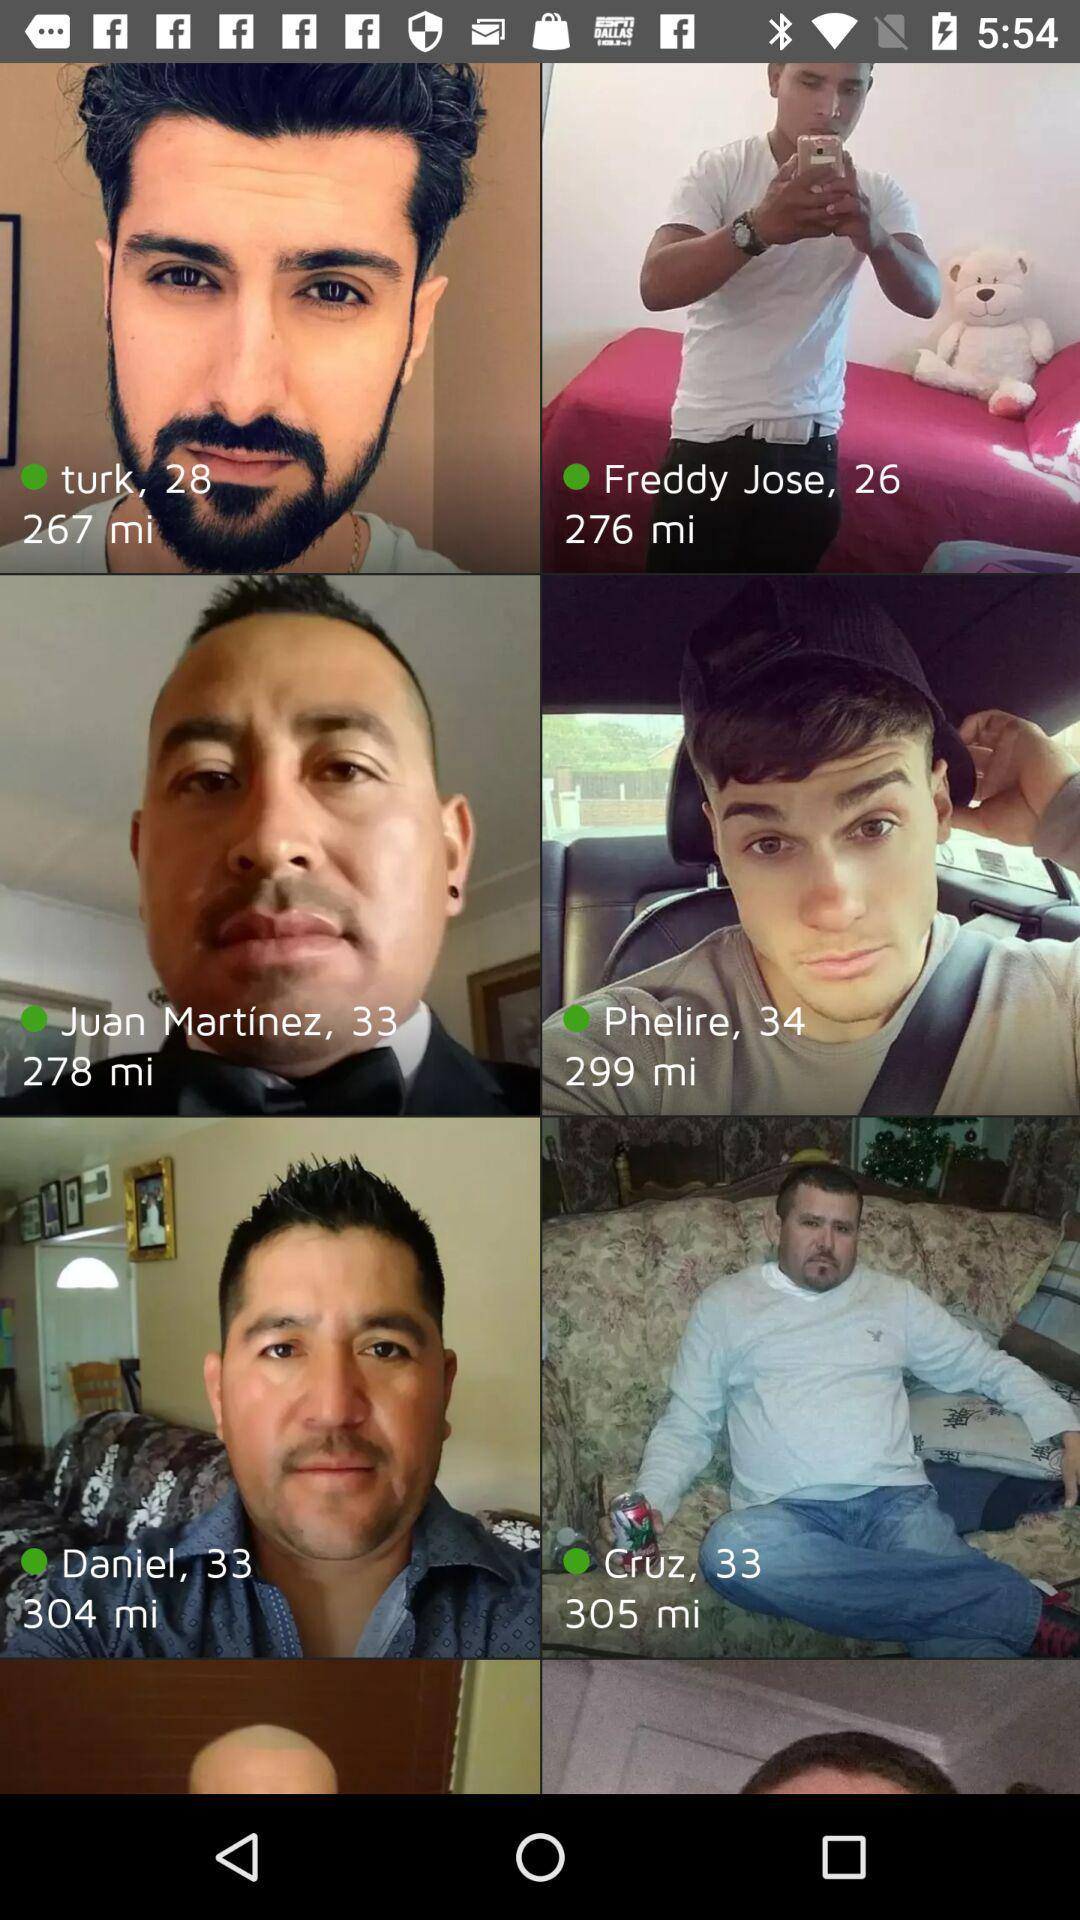How far away is Daniel? Daniel is 304 miles away. 